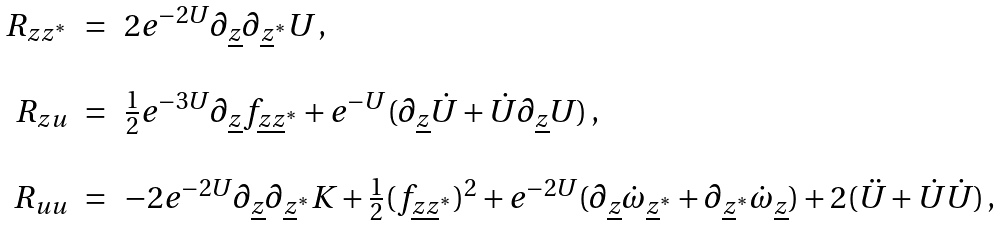Convert formula to latex. <formula><loc_0><loc_0><loc_500><loc_500>\begin{array} { r c l } R _ { z z ^ { * } } & = & 2 e ^ { - 2 U } \partial _ { \underline { z } } \partial _ { \underline { z } ^ { * } } U \, , \\ & & \\ R _ { z u } & = & { \frac { 1 } { 2 } } e ^ { - 3 U } \partial _ { \underline { z } } f _ { \underline { z } \underline { z } ^ { * } } + e ^ { - U } ( \partial _ { \underline { z } } \dot { U } + \dot { U } \partial _ { \underline { z } } U ) \, , \\ & & \\ R _ { u u } & = & - 2 e ^ { - 2 U } \partial _ { \underline { z } } \partial _ { \underline { z } ^ { * } } K + { \frac { 1 } { 2 } } ( f _ { \underline { z } \underline { z } ^ { * } } ) ^ { 2 } + e ^ { - 2 U } ( \partial _ { \underline { z } } \dot { \omega } _ { \underline { z } ^ { * } } + \partial _ { \underline { z } ^ { * } } \dot { \omega } _ { \underline { z } } ) + 2 ( \ddot { U } + \dot { U } \dot { U } ) \, , \\ \end{array}</formula> 